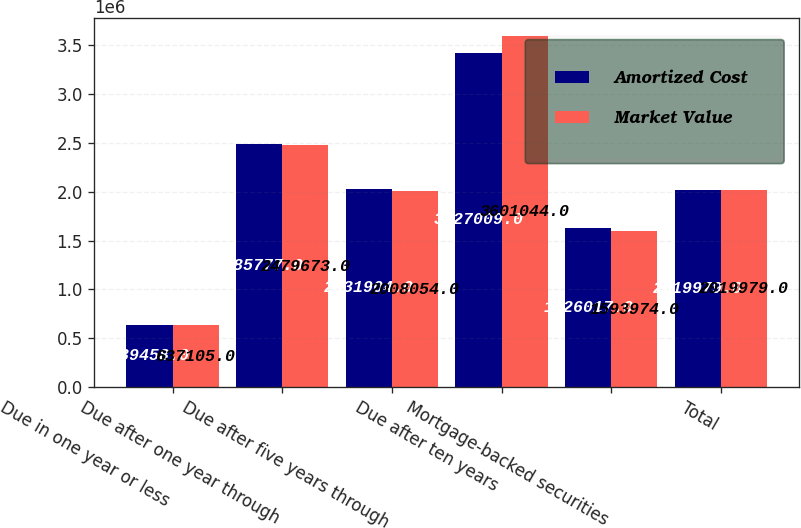Convert chart. <chart><loc_0><loc_0><loc_500><loc_500><stacked_bar_chart><ecel><fcel>Due in one year or less<fcel>Due after one year through<fcel>Due after five years through<fcel>Due after ten years<fcel>Mortgage-backed securities<fcel>Total<nl><fcel>Amortized Cost<fcel>639458<fcel>2.48578e+06<fcel>2.0319e+06<fcel>3.42701e+06<fcel>1.62602e+06<fcel>2.01998e+06<nl><fcel>Market Value<fcel>637105<fcel>2.47967e+06<fcel>2.00805e+06<fcel>3.60104e+06<fcel>1.59397e+06<fcel>2.01998e+06<nl></chart> 